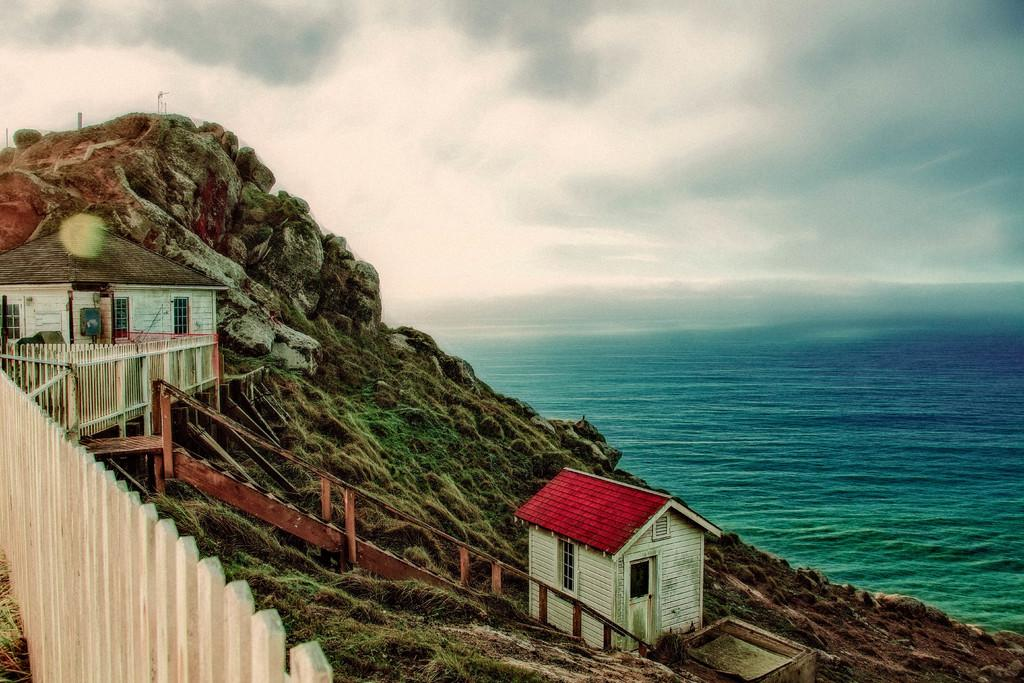How many houses are in the image? There are two houses in the image. What can be seen in the image besides the houses? There are stairs, a white-colored wooden wall, stones, and water visible in the image. What is the color of the wooden wall in the image? The wooden wall in the image is white-colored. What is visible in the background of the image? There are clouds, water, and the sky visible in the background of the image. How many cherries are on the wooden wall in the image? There are no cherries present on the wooden wall in the image. What type of ants can be seen crawling on the stairs in the image? There are no ants visible in the image, and therefore no such activity can be observed. 